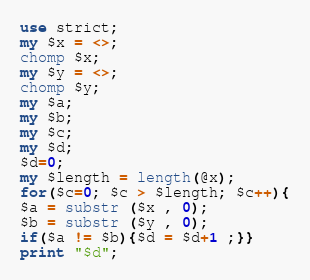<code> <loc_0><loc_0><loc_500><loc_500><_Perl_>use strict;
my $x = <>;
chomp $x;
my $y = <>;
chomp $y;
my $a;
my $b;
my $c;
my $d;
$d=0;
my $length = length(@x);
for($c=0; $c > $length; $c++){
$a = substr ($x , 0);
$b = substr ($y , 0);
if($a != $b){$d = $d+1 ;}}
print "$d";
</code> 